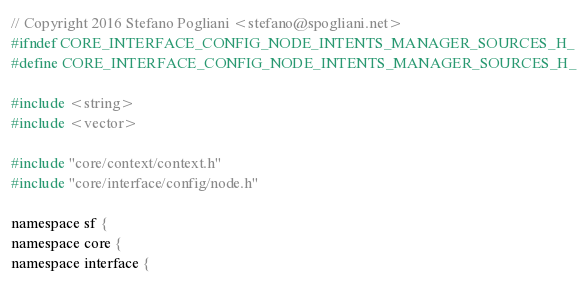Convert code to text. <code><loc_0><loc_0><loc_500><loc_500><_C_>// Copyright 2016 Stefano Pogliani <stefano@spogliani.net>
#ifndef CORE_INTERFACE_CONFIG_NODE_INTENTS_MANAGER_SOURCES_H_
#define CORE_INTERFACE_CONFIG_NODE_INTENTS_MANAGER_SOURCES_H_

#include <string>
#include <vector>

#include "core/context/context.h"
#include "core/interface/config/node.h"

namespace sf {
namespace core {
namespace interface {
</code> 